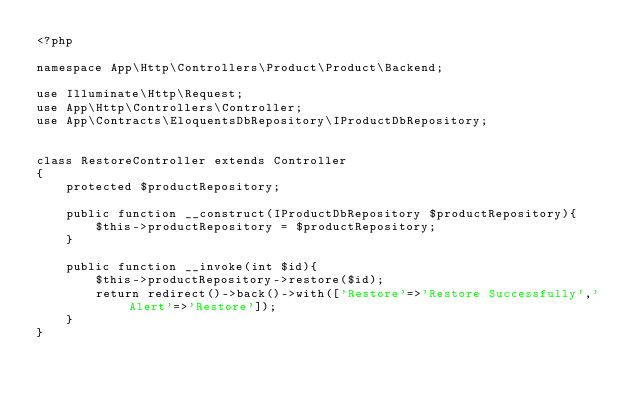Convert code to text. <code><loc_0><loc_0><loc_500><loc_500><_PHP_><?php

namespace App\Http\Controllers\Product\Product\Backend;

use Illuminate\Http\Request;
use App\Http\Controllers\Controller;
use App\Contracts\EloquentsDbRepository\IProductDbRepository;


class RestoreController extends Controller
{
    protected $productRepository;

    public function __construct(IProductDbRepository $productRepository){
        $this->productRepository = $productRepository;
    }

    public function __invoke(int $id){
        $this->productRepository->restore($id);
        return redirect()->back()->with(['Restore'=>'Restore Successfully','Alert'=>'Restore']);
    }
}
</code> 